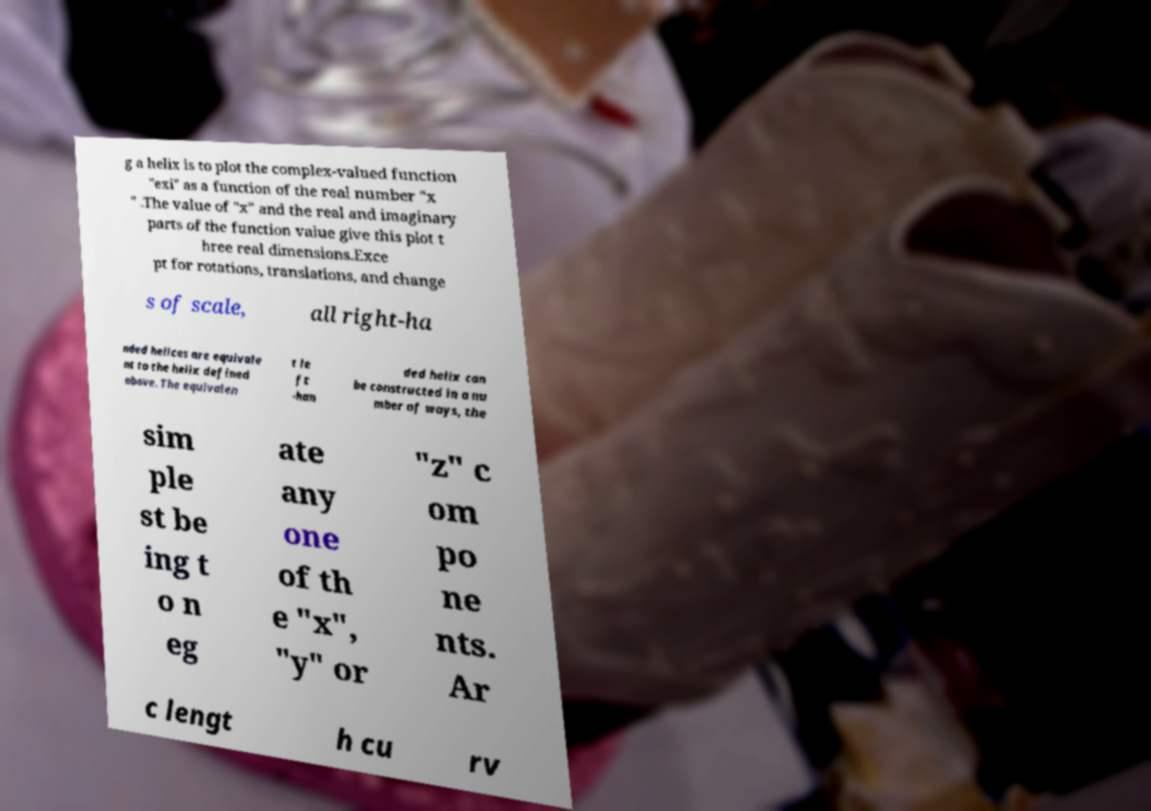Please read and relay the text visible in this image. What does it say? g a helix is to plot the complex-valued function "exi" as a function of the real number "x " .The value of "x" and the real and imaginary parts of the function value give this plot t hree real dimensions.Exce pt for rotations, translations, and change s of scale, all right-ha nded helices are equivale nt to the helix defined above. The equivalen t le ft -han ded helix can be constructed in a nu mber of ways, the sim ple st be ing t o n eg ate any one of th e "x", "y" or "z" c om po ne nts. Ar c lengt h cu rv 